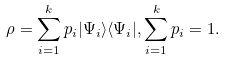Convert formula to latex. <formula><loc_0><loc_0><loc_500><loc_500>\rho = \sum _ { i = 1 } ^ { k } p _ { i } | \Psi _ { i } \rangle \langle \Psi _ { i } | , \sum _ { i = 1 } ^ { k } p _ { i } = 1 .</formula> 